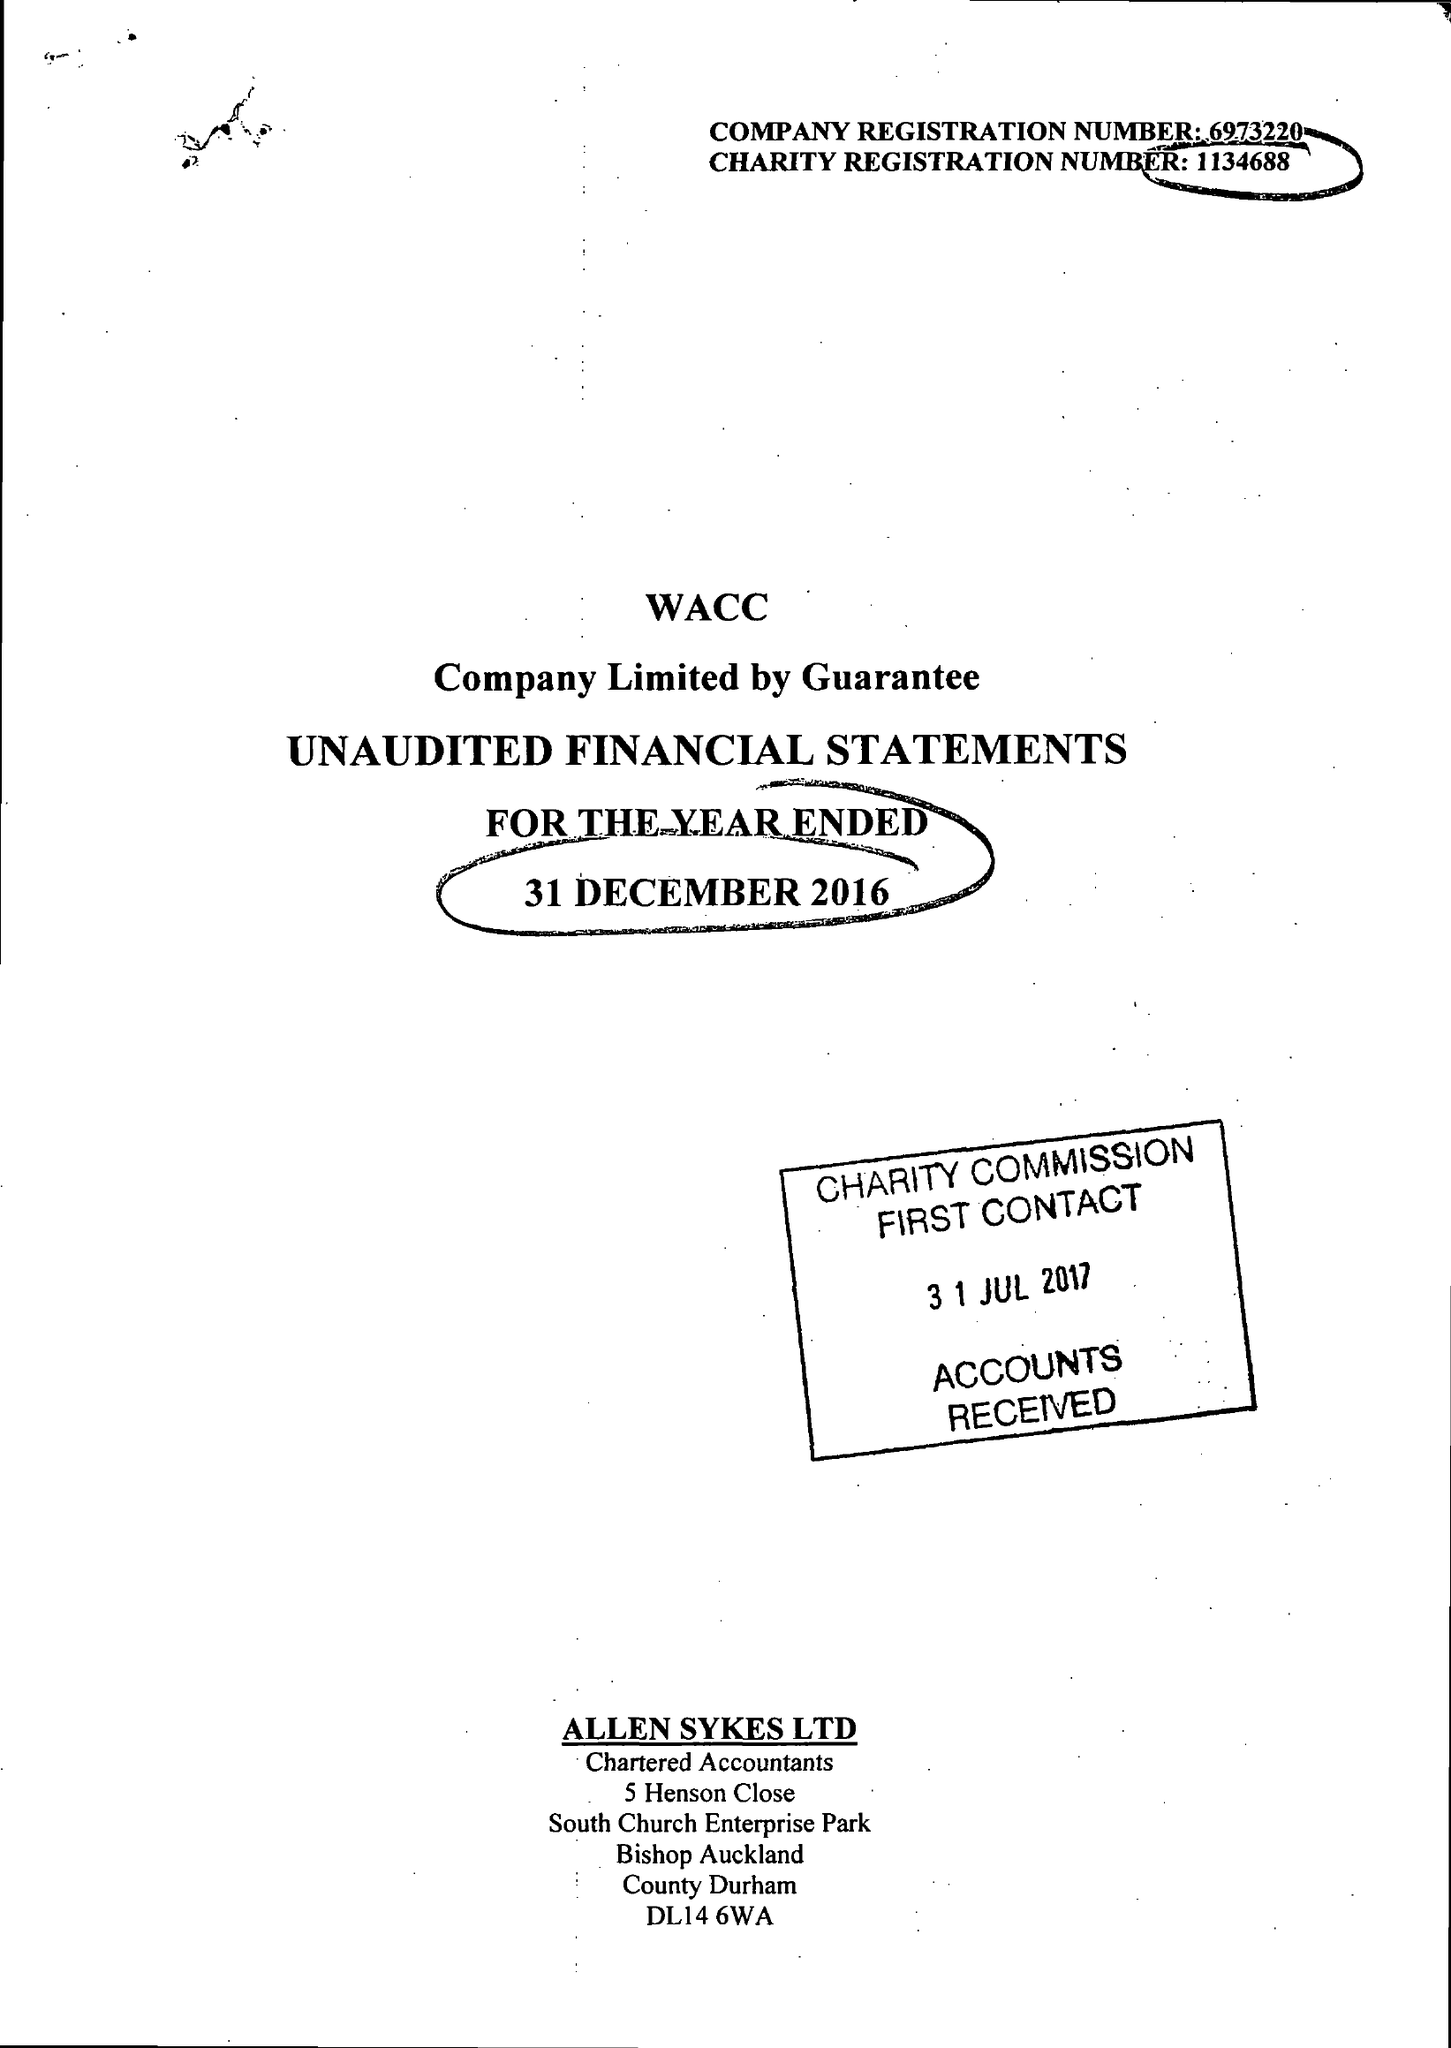What is the value for the address__post_town?
Answer the question using a single word or phrase. BISHOP AUCKLAND 